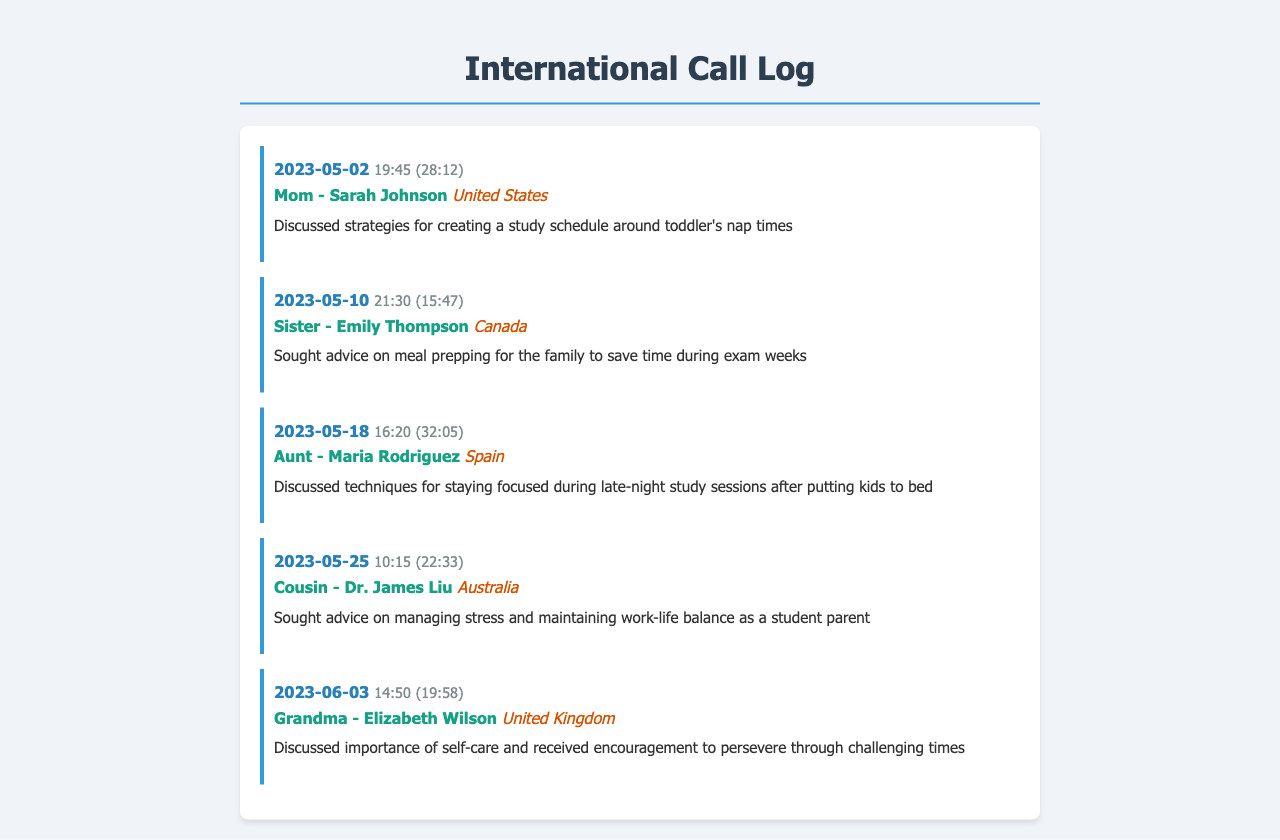What is the date of the first call in the log? The date of the first call is indicated in the first entry of the log, which is May 2, 2023.
Answer: 2023-05-02 Who did the second call take place with? The second call entry mentions that it was with the caller's sister, Emily Thompson.
Answer: Sister - Emily Thompson How long was the call made to Grandma? The duration of the call to Grandma, Elizabeth Wilson, is recorded in the log as 19 minutes and 58 seconds.
Answer: 19:58 What was discussed in the call with Aunt Maria? The notes for the call with Aunt Maria mention that techniques for staying focused during late-night study sessions were discussed.
Answer: Staying focused during late-night study sessions Which family member suggested meal prepping? The call notes indicate that meal prepping advice was sought from the caller's sister, Emily Thompson.
Answer: Sister - Emily Thompson How many calls were made to family members in total? By counting the individual call entries, a total of five calls were logged.
Answer: 5 What country did the caller's aunt live in? The call entry with Aunt Maria explicitly states that she is located in Spain.
Answer: Spain 